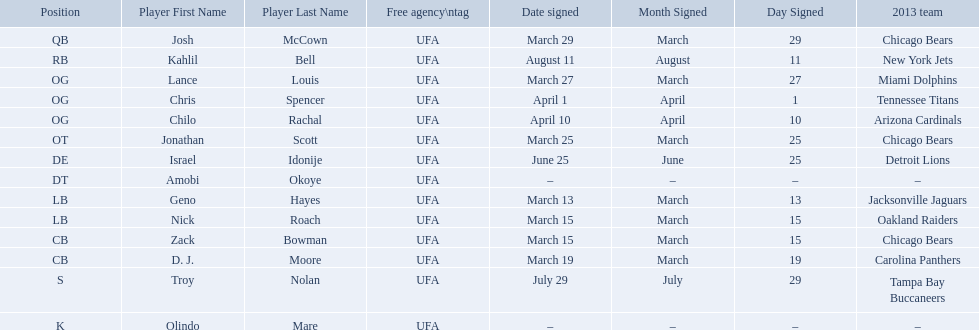What are all the dates signed? March 29, August 11, March 27, April 1, April 10, March 25, June 25, March 13, March 15, March 15, March 19, July 29. Which of these are duplicates? March 15, March 15. Who has the same one as nick roach? Zack Bowman. Who are all the players on the 2013 chicago bears season team? Josh McCown, Kahlil Bell, Lance Louis, Chris Spencer, Chilo Rachal, Jonathan Scott, Israel Idonije, Amobi Okoye, Geno Hayes, Nick Roach, Zack Bowman, D. J. Moore, Troy Nolan, Olindo Mare. What day was nick roach signed? March 15. What other day matches this? March 15. Who was signed on the day? Zack Bowman. 